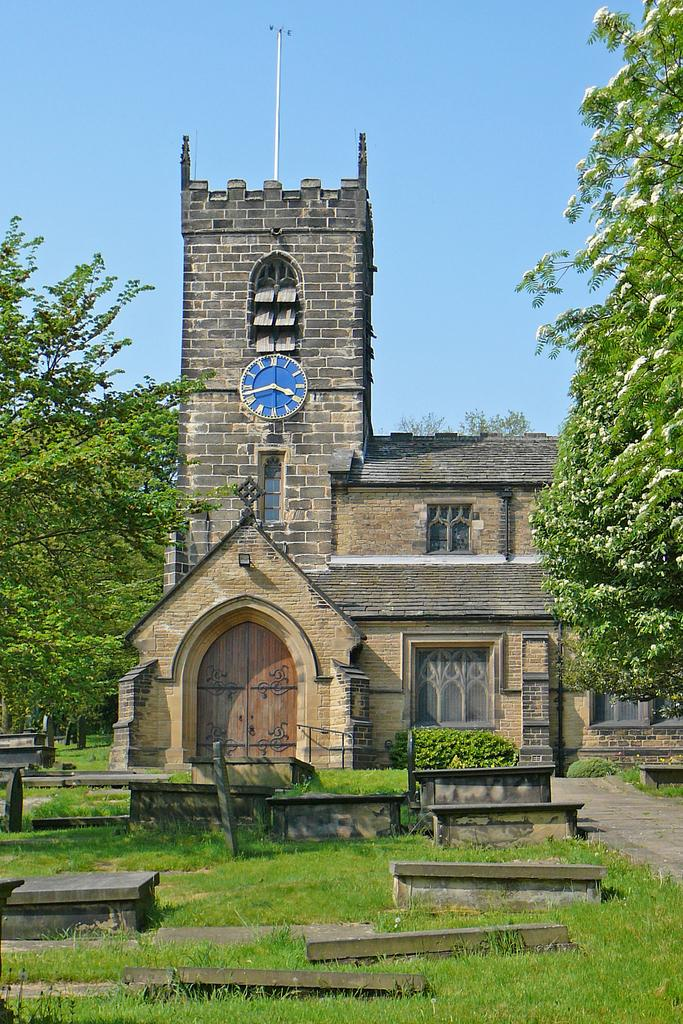What type of vegetation can be seen in the image? There is grass and plants in the image. What type of structure is present in the image? There is a building in the image. What architectural feature can be seen on the building? There are windows in the image. What else can be seen in the image besides the building and vegetation? There are trees in the image. What part of the natural environment is visible in the image? The sky is visible in the image. What type of clock is present in the image? There is a blue color clock in the image. What position does the machine hold in the image? There is no machine present in the image. How does the good-bye wave look like in the image? There is no good-bye wave or any indication of a farewell in the image. 